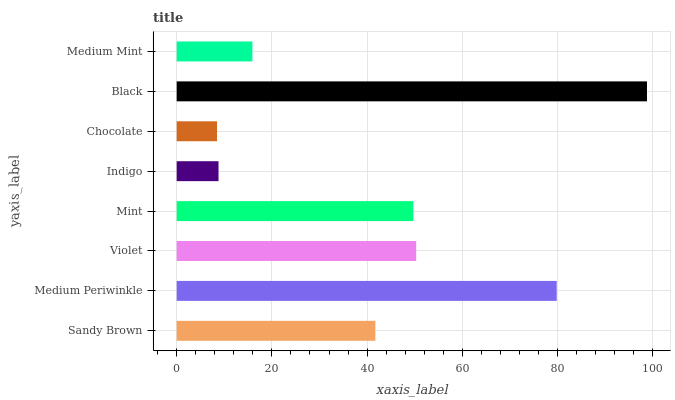Is Chocolate the minimum?
Answer yes or no. Yes. Is Black the maximum?
Answer yes or no. Yes. Is Medium Periwinkle the minimum?
Answer yes or no. No. Is Medium Periwinkle the maximum?
Answer yes or no. No. Is Medium Periwinkle greater than Sandy Brown?
Answer yes or no. Yes. Is Sandy Brown less than Medium Periwinkle?
Answer yes or no. Yes. Is Sandy Brown greater than Medium Periwinkle?
Answer yes or no. No. Is Medium Periwinkle less than Sandy Brown?
Answer yes or no. No. Is Mint the high median?
Answer yes or no. Yes. Is Sandy Brown the low median?
Answer yes or no. Yes. Is Chocolate the high median?
Answer yes or no. No. Is Indigo the low median?
Answer yes or no. No. 